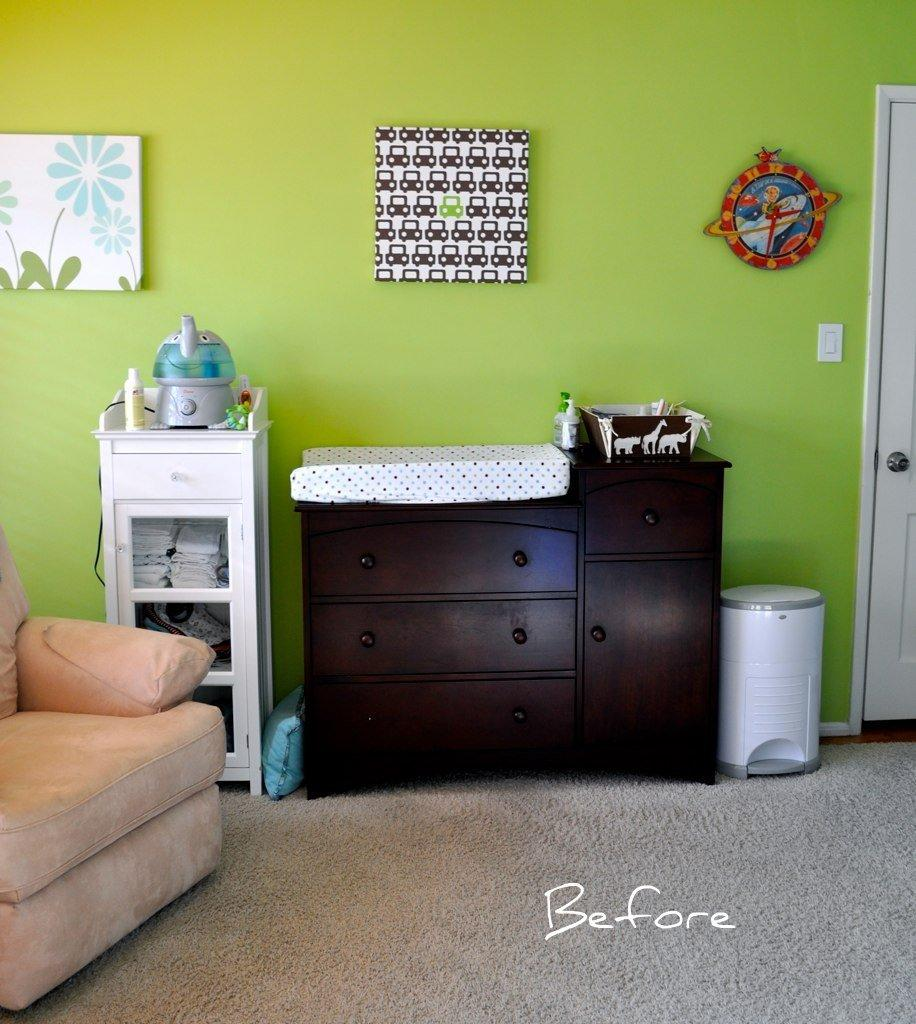Provide a one-sentence caption for the provided image. A Before picture of a room wht a green wall and a changing table. 